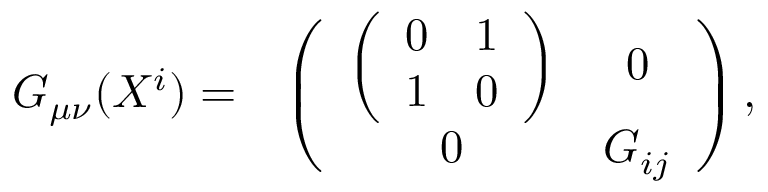<formula> <loc_0><loc_0><loc_500><loc_500>\begin{array} { c c } { { G _ { \mu \nu } ( X ^ { i } ) = } } & { { \left ( \begin{array} { c c } { { \left ( \begin{array} { c c } { 0 } & { 1 } \\ { 1 } & { 0 } \end{array} \right ) } } & { 0 } \\ { 0 } & { { G _ { i j } } } \end{array} \right ) , } } \end{array}</formula> 